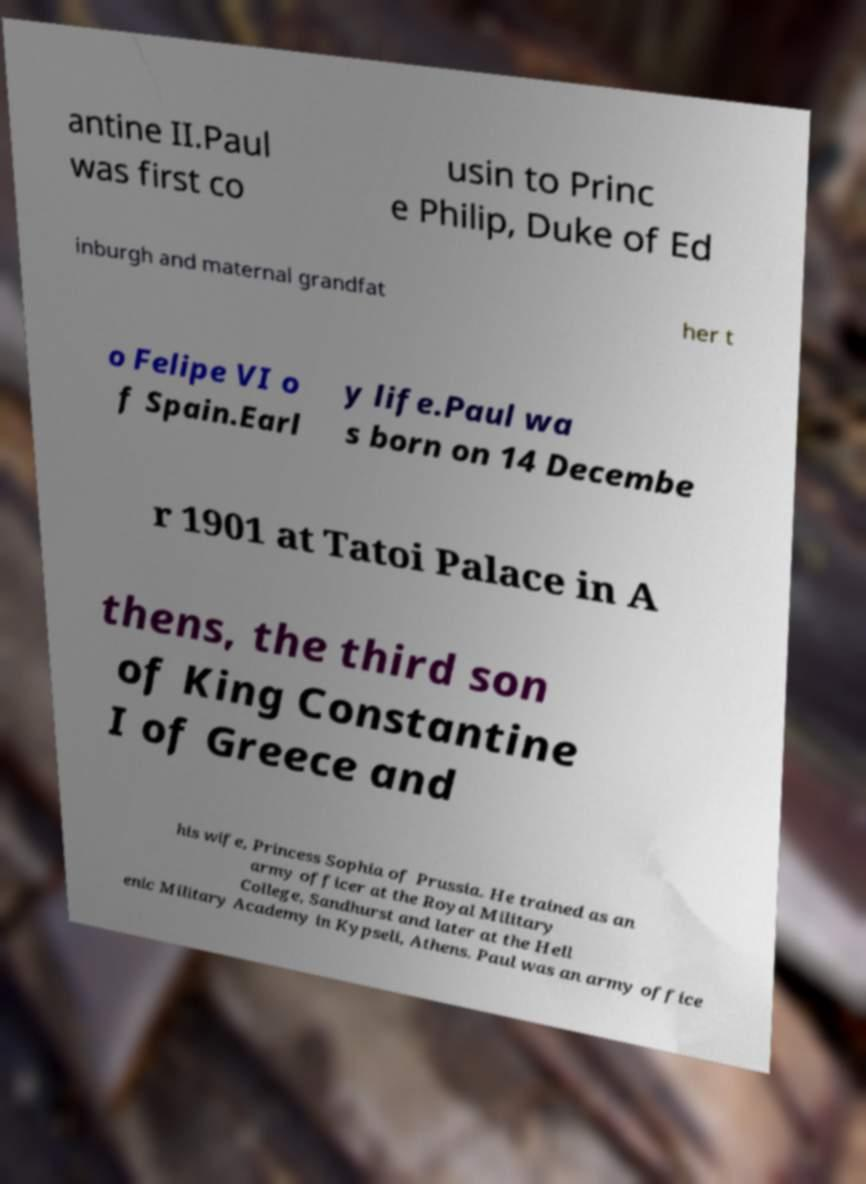There's text embedded in this image that I need extracted. Can you transcribe it verbatim? antine II.Paul was first co usin to Princ e Philip, Duke of Ed inburgh and maternal grandfat her t o Felipe VI o f Spain.Earl y life.Paul wa s born on 14 Decembe r 1901 at Tatoi Palace in A thens, the third son of King Constantine I of Greece and his wife, Princess Sophia of Prussia. He trained as an army officer at the Royal Military College, Sandhurst and later at the Hell enic Military Academy in Kypseli, Athens. Paul was an army office 